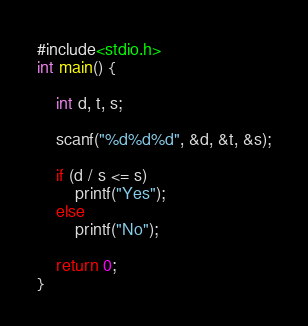<code> <loc_0><loc_0><loc_500><loc_500><_C_>#include<stdio.h>
int main() {

	int d, t, s;

	scanf("%d%d%d", &d, &t, &s);

	if (d / s <= s)
		printf("Yes");
	else
		printf("No");

	return 0;
}</code> 